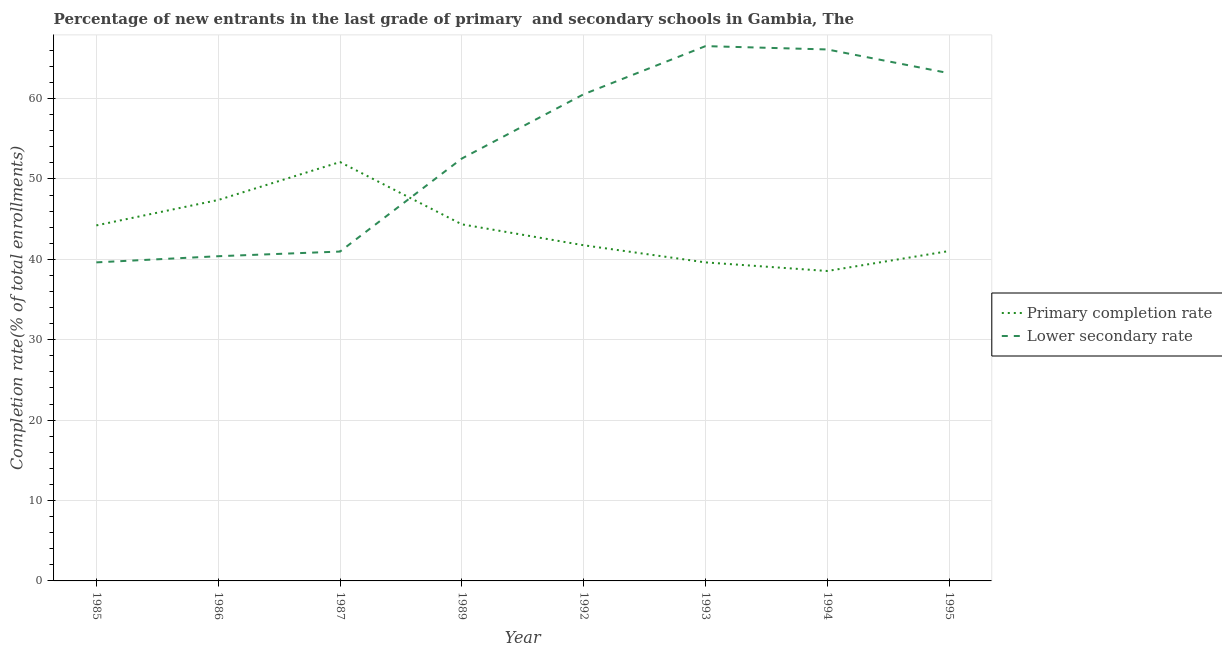How many different coloured lines are there?
Your answer should be compact. 2. Does the line corresponding to completion rate in secondary schools intersect with the line corresponding to completion rate in primary schools?
Keep it short and to the point. Yes. What is the completion rate in secondary schools in 1993?
Offer a very short reply. 66.53. Across all years, what is the maximum completion rate in primary schools?
Give a very brief answer. 52.11. Across all years, what is the minimum completion rate in secondary schools?
Give a very brief answer. 39.63. In which year was the completion rate in primary schools maximum?
Offer a very short reply. 1987. What is the total completion rate in secondary schools in the graph?
Offer a terse response. 429.88. What is the difference between the completion rate in primary schools in 1993 and that in 1995?
Your answer should be very brief. -1.41. What is the difference between the completion rate in primary schools in 1994 and the completion rate in secondary schools in 1992?
Offer a terse response. -21.99. What is the average completion rate in primary schools per year?
Provide a succinct answer. 43.63. In the year 1993, what is the difference between the completion rate in secondary schools and completion rate in primary schools?
Your answer should be compact. 26.9. In how many years, is the completion rate in primary schools greater than 40 %?
Give a very brief answer. 6. What is the ratio of the completion rate in primary schools in 1986 to that in 1994?
Make the answer very short. 1.23. Is the completion rate in primary schools in 1993 less than that in 1995?
Provide a succinct answer. Yes. What is the difference between the highest and the second highest completion rate in secondary schools?
Your answer should be compact. 0.42. What is the difference between the highest and the lowest completion rate in primary schools?
Offer a terse response. 13.55. Does the completion rate in secondary schools monotonically increase over the years?
Ensure brevity in your answer.  No. Is the completion rate in primary schools strictly greater than the completion rate in secondary schools over the years?
Your response must be concise. No. Is the completion rate in primary schools strictly less than the completion rate in secondary schools over the years?
Offer a terse response. No. What is the difference between two consecutive major ticks on the Y-axis?
Your answer should be very brief. 10. Does the graph contain any zero values?
Your answer should be compact. No. How many legend labels are there?
Keep it short and to the point. 2. How are the legend labels stacked?
Offer a very short reply. Vertical. What is the title of the graph?
Your answer should be compact. Percentage of new entrants in the last grade of primary  and secondary schools in Gambia, The. Does "Register a property" appear as one of the legend labels in the graph?
Keep it short and to the point. No. What is the label or title of the X-axis?
Provide a short and direct response. Year. What is the label or title of the Y-axis?
Your answer should be compact. Completion rate(% of total enrollments). What is the Completion rate(% of total enrollments) in Primary completion rate in 1985?
Your answer should be compact. 44.23. What is the Completion rate(% of total enrollments) of Lower secondary rate in 1985?
Provide a short and direct response. 39.63. What is the Completion rate(% of total enrollments) of Primary completion rate in 1986?
Keep it short and to the point. 47.39. What is the Completion rate(% of total enrollments) in Lower secondary rate in 1986?
Ensure brevity in your answer.  40.39. What is the Completion rate(% of total enrollments) of Primary completion rate in 1987?
Provide a succinct answer. 52.11. What is the Completion rate(% of total enrollments) in Lower secondary rate in 1987?
Keep it short and to the point. 40.97. What is the Completion rate(% of total enrollments) in Primary completion rate in 1989?
Offer a very short reply. 44.36. What is the Completion rate(% of total enrollments) in Lower secondary rate in 1989?
Your response must be concise. 52.55. What is the Completion rate(% of total enrollments) of Primary completion rate in 1992?
Keep it short and to the point. 41.76. What is the Completion rate(% of total enrollments) of Lower secondary rate in 1992?
Give a very brief answer. 60.54. What is the Completion rate(% of total enrollments) of Primary completion rate in 1993?
Ensure brevity in your answer.  39.63. What is the Completion rate(% of total enrollments) of Lower secondary rate in 1993?
Your answer should be compact. 66.53. What is the Completion rate(% of total enrollments) of Primary completion rate in 1994?
Your response must be concise. 38.55. What is the Completion rate(% of total enrollments) in Lower secondary rate in 1994?
Your answer should be very brief. 66.11. What is the Completion rate(% of total enrollments) of Primary completion rate in 1995?
Provide a short and direct response. 41.04. What is the Completion rate(% of total enrollments) of Lower secondary rate in 1995?
Your answer should be very brief. 63.16. Across all years, what is the maximum Completion rate(% of total enrollments) of Primary completion rate?
Give a very brief answer. 52.11. Across all years, what is the maximum Completion rate(% of total enrollments) in Lower secondary rate?
Make the answer very short. 66.53. Across all years, what is the minimum Completion rate(% of total enrollments) of Primary completion rate?
Provide a short and direct response. 38.55. Across all years, what is the minimum Completion rate(% of total enrollments) in Lower secondary rate?
Keep it short and to the point. 39.63. What is the total Completion rate(% of total enrollments) of Primary completion rate in the graph?
Provide a short and direct response. 349.05. What is the total Completion rate(% of total enrollments) in Lower secondary rate in the graph?
Make the answer very short. 429.88. What is the difference between the Completion rate(% of total enrollments) in Primary completion rate in 1985 and that in 1986?
Provide a short and direct response. -3.16. What is the difference between the Completion rate(% of total enrollments) in Lower secondary rate in 1985 and that in 1986?
Give a very brief answer. -0.77. What is the difference between the Completion rate(% of total enrollments) in Primary completion rate in 1985 and that in 1987?
Ensure brevity in your answer.  -7.88. What is the difference between the Completion rate(% of total enrollments) in Lower secondary rate in 1985 and that in 1987?
Ensure brevity in your answer.  -1.35. What is the difference between the Completion rate(% of total enrollments) of Primary completion rate in 1985 and that in 1989?
Provide a short and direct response. -0.13. What is the difference between the Completion rate(% of total enrollments) of Lower secondary rate in 1985 and that in 1989?
Your answer should be compact. -12.92. What is the difference between the Completion rate(% of total enrollments) of Primary completion rate in 1985 and that in 1992?
Your answer should be compact. 2.47. What is the difference between the Completion rate(% of total enrollments) in Lower secondary rate in 1985 and that in 1992?
Offer a terse response. -20.92. What is the difference between the Completion rate(% of total enrollments) in Primary completion rate in 1985 and that in 1993?
Your response must be concise. 4.6. What is the difference between the Completion rate(% of total enrollments) in Lower secondary rate in 1985 and that in 1993?
Provide a succinct answer. -26.9. What is the difference between the Completion rate(% of total enrollments) of Primary completion rate in 1985 and that in 1994?
Keep it short and to the point. 5.67. What is the difference between the Completion rate(% of total enrollments) in Lower secondary rate in 1985 and that in 1994?
Provide a short and direct response. -26.49. What is the difference between the Completion rate(% of total enrollments) in Primary completion rate in 1985 and that in 1995?
Give a very brief answer. 3.19. What is the difference between the Completion rate(% of total enrollments) in Lower secondary rate in 1985 and that in 1995?
Provide a short and direct response. -23.53. What is the difference between the Completion rate(% of total enrollments) of Primary completion rate in 1986 and that in 1987?
Offer a very short reply. -4.72. What is the difference between the Completion rate(% of total enrollments) of Lower secondary rate in 1986 and that in 1987?
Your answer should be compact. -0.58. What is the difference between the Completion rate(% of total enrollments) of Primary completion rate in 1986 and that in 1989?
Provide a succinct answer. 3.03. What is the difference between the Completion rate(% of total enrollments) of Lower secondary rate in 1986 and that in 1989?
Provide a succinct answer. -12.15. What is the difference between the Completion rate(% of total enrollments) in Primary completion rate in 1986 and that in 1992?
Your answer should be compact. 5.63. What is the difference between the Completion rate(% of total enrollments) in Lower secondary rate in 1986 and that in 1992?
Provide a succinct answer. -20.15. What is the difference between the Completion rate(% of total enrollments) in Primary completion rate in 1986 and that in 1993?
Offer a very short reply. 7.76. What is the difference between the Completion rate(% of total enrollments) of Lower secondary rate in 1986 and that in 1993?
Ensure brevity in your answer.  -26.14. What is the difference between the Completion rate(% of total enrollments) in Primary completion rate in 1986 and that in 1994?
Your answer should be compact. 8.83. What is the difference between the Completion rate(% of total enrollments) of Lower secondary rate in 1986 and that in 1994?
Ensure brevity in your answer.  -25.72. What is the difference between the Completion rate(% of total enrollments) in Primary completion rate in 1986 and that in 1995?
Your answer should be very brief. 6.35. What is the difference between the Completion rate(% of total enrollments) in Lower secondary rate in 1986 and that in 1995?
Your answer should be compact. -22.76. What is the difference between the Completion rate(% of total enrollments) of Primary completion rate in 1987 and that in 1989?
Keep it short and to the point. 7.75. What is the difference between the Completion rate(% of total enrollments) of Lower secondary rate in 1987 and that in 1989?
Provide a short and direct response. -11.57. What is the difference between the Completion rate(% of total enrollments) of Primary completion rate in 1987 and that in 1992?
Your response must be concise. 10.35. What is the difference between the Completion rate(% of total enrollments) in Lower secondary rate in 1987 and that in 1992?
Provide a short and direct response. -19.57. What is the difference between the Completion rate(% of total enrollments) of Primary completion rate in 1987 and that in 1993?
Your answer should be very brief. 12.48. What is the difference between the Completion rate(% of total enrollments) in Lower secondary rate in 1987 and that in 1993?
Provide a succinct answer. -25.56. What is the difference between the Completion rate(% of total enrollments) in Primary completion rate in 1987 and that in 1994?
Give a very brief answer. 13.55. What is the difference between the Completion rate(% of total enrollments) in Lower secondary rate in 1987 and that in 1994?
Ensure brevity in your answer.  -25.14. What is the difference between the Completion rate(% of total enrollments) of Primary completion rate in 1987 and that in 1995?
Ensure brevity in your answer.  11.07. What is the difference between the Completion rate(% of total enrollments) of Lower secondary rate in 1987 and that in 1995?
Your answer should be very brief. -22.19. What is the difference between the Completion rate(% of total enrollments) in Primary completion rate in 1989 and that in 1992?
Your answer should be compact. 2.6. What is the difference between the Completion rate(% of total enrollments) of Lower secondary rate in 1989 and that in 1992?
Give a very brief answer. -8. What is the difference between the Completion rate(% of total enrollments) of Primary completion rate in 1989 and that in 1993?
Your answer should be very brief. 4.73. What is the difference between the Completion rate(% of total enrollments) of Lower secondary rate in 1989 and that in 1993?
Your response must be concise. -13.98. What is the difference between the Completion rate(% of total enrollments) of Primary completion rate in 1989 and that in 1994?
Offer a very short reply. 5.8. What is the difference between the Completion rate(% of total enrollments) in Lower secondary rate in 1989 and that in 1994?
Offer a terse response. -13.57. What is the difference between the Completion rate(% of total enrollments) in Primary completion rate in 1989 and that in 1995?
Keep it short and to the point. 3.32. What is the difference between the Completion rate(% of total enrollments) of Lower secondary rate in 1989 and that in 1995?
Your answer should be very brief. -10.61. What is the difference between the Completion rate(% of total enrollments) of Primary completion rate in 1992 and that in 1993?
Your answer should be very brief. 2.13. What is the difference between the Completion rate(% of total enrollments) in Lower secondary rate in 1992 and that in 1993?
Your response must be concise. -5.99. What is the difference between the Completion rate(% of total enrollments) in Primary completion rate in 1992 and that in 1994?
Keep it short and to the point. 3.2. What is the difference between the Completion rate(% of total enrollments) in Lower secondary rate in 1992 and that in 1994?
Keep it short and to the point. -5.57. What is the difference between the Completion rate(% of total enrollments) of Primary completion rate in 1992 and that in 1995?
Give a very brief answer. 0.72. What is the difference between the Completion rate(% of total enrollments) in Lower secondary rate in 1992 and that in 1995?
Your response must be concise. -2.62. What is the difference between the Completion rate(% of total enrollments) of Primary completion rate in 1993 and that in 1994?
Give a very brief answer. 1.07. What is the difference between the Completion rate(% of total enrollments) in Lower secondary rate in 1993 and that in 1994?
Offer a very short reply. 0.42. What is the difference between the Completion rate(% of total enrollments) of Primary completion rate in 1993 and that in 1995?
Offer a terse response. -1.41. What is the difference between the Completion rate(% of total enrollments) in Lower secondary rate in 1993 and that in 1995?
Your response must be concise. 3.37. What is the difference between the Completion rate(% of total enrollments) in Primary completion rate in 1994 and that in 1995?
Give a very brief answer. -2.48. What is the difference between the Completion rate(% of total enrollments) of Lower secondary rate in 1994 and that in 1995?
Provide a short and direct response. 2.96. What is the difference between the Completion rate(% of total enrollments) in Primary completion rate in 1985 and the Completion rate(% of total enrollments) in Lower secondary rate in 1986?
Make the answer very short. 3.83. What is the difference between the Completion rate(% of total enrollments) in Primary completion rate in 1985 and the Completion rate(% of total enrollments) in Lower secondary rate in 1987?
Offer a very short reply. 3.26. What is the difference between the Completion rate(% of total enrollments) in Primary completion rate in 1985 and the Completion rate(% of total enrollments) in Lower secondary rate in 1989?
Your response must be concise. -8.32. What is the difference between the Completion rate(% of total enrollments) in Primary completion rate in 1985 and the Completion rate(% of total enrollments) in Lower secondary rate in 1992?
Offer a very short reply. -16.31. What is the difference between the Completion rate(% of total enrollments) in Primary completion rate in 1985 and the Completion rate(% of total enrollments) in Lower secondary rate in 1993?
Provide a succinct answer. -22.3. What is the difference between the Completion rate(% of total enrollments) in Primary completion rate in 1985 and the Completion rate(% of total enrollments) in Lower secondary rate in 1994?
Make the answer very short. -21.89. What is the difference between the Completion rate(% of total enrollments) of Primary completion rate in 1985 and the Completion rate(% of total enrollments) of Lower secondary rate in 1995?
Make the answer very short. -18.93. What is the difference between the Completion rate(% of total enrollments) of Primary completion rate in 1986 and the Completion rate(% of total enrollments) of Lower secondary rate in 1987?
Your response must be concise. 6.41. What is the difference between the Completion rate(% of total enrollments) in Primary completion rate in 1986 and the Completion rate(% of total enrollments) in Lower secondary rate in 1989?
Provide a succinct answer. -5.16. What is the difference between the Completion rate(% of total enrollments) of Primary completion rate in 1986 and the Completion rate(% of total enrollments) of Lower secondary rate in 1992?
Provide a succinct answer. -13.16. What is the difference between the Completion rate(% of total enrollments) in Primary completion rate in 1986 and the Completion rate(% of total enrollments) in Lower secondary rate in 1993?
Make the answer very short. -19.14. What is the difference between the Completion rate(% of total enrollments) of Primary completion rate in 1986 and the Completion rate(% of total enrollments) of Lower secondary rate in 1994?
Provide a succinct answer. -18.73. What is the difference between the Completion rate(% of total enrollments) in Primary completion rate in 1986 and the Completion rate(% of total enrollments) in Lower secondary rate in 1995?
Your answer should be compact. -15.77. What is the difference between the Completion rate(% of total enrollments) in Primary completion rate in 1987 and the Completion rate(% of total enrollments) in Lower secondary rate in 1989?
Your answer should be very brief. -0.44. What is the difference between the Completion rate(% of total enrollments) in Primary completion rate in 1987 and the Completion rate(% of total enrollments) in Lower secondary rate in 1992?
Your response must be concise. -8.44. What is the difference between the Completion rate(% of total enrollments) in Primary completion rate in 1987 and the Completion rate(% of total enrollments) in Lower secondary rate in 1993?
Offer a terse response. -14.42. What is the difference between the Completion rate(% of total enrollments) of Primary completion rate in 1987 and the Completion rate(% of total enrollments) of Lower secondary rate in 1994?
Keep it short and to the point. -14.01. What is the difference between the Completion rate(% of total enrollments) in Primary completion rate in 1987 and the Completion rate(% of total enrollments) in Lower secondary rate in 1995?
Offer a terse response. -11.05. What is the difference between the Completion rate(% of total enrollments) of Primary completion rate in 1989 and the Completion rate(% of total enrollments) of Lower secondary rate in 1992?
Provide a succinct answer. -16.18. What is the difference between the Completion rate(% of total enrollments) of Primary completion rate in 1989 and the Completion rate(% of total enrollments) of Lower secondary rate in 1993?
Keep it short and to the point. -22.17. What is the difference between the Completion rate(% of total enrollments) of Primary completion rate in 1989 and the Completion rate(% of total enrollments) of Lower secondary rate in 1994?
Offer a very short reply. -21.75. What is the difference between the Completion rate(% of total enrollments) of Primary completion rate in 1989 and the Completion rate(% of total enrollments) of Lower secondary rate in 1995?
Keep it short and to the point. -18.8. What is the difference between the Completion rate(% of total enrollments) in Primary completion rate in 1992 and the Completion rate(% of total enrollments) in Lower secondary rate in 1993?
Your response must be concise. -24.77. What is the difference between the Completion rate(% of total enrollments) in Primary completion rate in 1992 and the Completion rate(% of total enrollments) in Lower secondary rate in 1994?
Your answer should be compact. -24.36. What is the difference between the Completion rate(% of total enrollments) in Primary completion rate in 1992 and the Completion rate(% of total enrollments) in Lower secondary rate in 1995?
Your answer should be compact. -21.4. What is the difference between the Completion rate(% of total enrollments) of Primary completion rate in 1993 and the Completion rate(% of total enrollments) of Lower secondary rate in 1994?
Provide a succinct answer. -26.49. What is the difference between the Completion rate(% of total enrollments) in Primary completion rate in 1993 and the Completion rate(% of total enrollments) in Lower secondary rate in 1995?
Offer a terse response. -23.53. What is the difference between the Completion rate(% of total enrollments) in Primary completion rate in 1994 and the Completion rate(% of total enrollments) in Lower secondary rate in 1995?
Offer a very short reply. -24.6. What is the average Completion rate(% of total enrollments) in Primary completion rate per year?
Give a very brief answer. 43.63. What is the average Completion rate(% of total enrollments) in Lower secondary rate per year?
Ensure brevity in your answer.  53.73. In the year 1985, what is the difference between the Completion rate(% of total enrollments) of Primary completion rate and Completion rate(% of total enrollments) of Lower secondary rate?
Give a very brief answer. 4.6. In the year 1986, what is the difference between the Completion rate(% of total enrollments) in Primary completion rate and Completion rate(% of total enrollments) in Lower secondary rate?
Offer a very short reply. 6.99. In the year 1987, what is the difference between the Completion rate(% of total enrollments) in Primary completion rate and Completion rate(% of total enrollments) in Lower secondary rate?
Your answer should be compact. 11.13. In the year 1989, what is the difference between the Completion rate(% of total enrollments) of Primary completion rate and Completion rate(% of total enrollments) of Lower secondary rate?
Give a very brief answer. -8.19. In the year 1992, what is the difference between the Completion rate(% of total enrollments) of Primary completion rate and Completion rate(% of total enrollments) of Lower secondary rate?
Your answer should be compact. -18.79. In the year 1993, what is the difference between the Completion rate(% of total enrollments) in Primary completion rate and Completion rate(% of total enrollments) in Lower secondary rate?
Offer a terse response. -26.9. In the year 1994, what is the difference between the Completion rate(% of total enrollments) in Primary completion rate and Completion rate(% of total enrollments) in Lower secondary rate?
Your answer should be very brief. -27.56. In the year 1995, what is the difference between the Completion rate(% of total enrollments) in Primary completion rate and Completion rate(% of total enrollments) in Lower secondary rate?
Your answer should be very brief. -22.12. What is the ratio of the Completion rate(% of total enrollments) in Lower secondary rate in 1985 to that in 1986?
Keep it short and to the point. 0.98. What is the ratio of the Completion rate(% of total enrollments) of Primary completion rate in 1985 to that in 1987?
Make the answer very short. 0.85. What is the ratio of the Completion rate(% of total enrollments) in Lower secondary rate in 1985 to that in 1987?
Give a very brief answer. 0.97. What is the ratio of the Completion rate(% of total enrollments) of Lower secondary rate in 1985 to that in 1989?
Make the answer very short. 0.75. What is the ratio of the Completion rate(% of total enrollments) of Primary completion rate in 1985 to that in 1992?
Offer a terse response. 1.06. What is the ratio of the Completion rate(% of total enrollments) in Lower secondary rate in 1985 to that in 1992?
Your answer should be compact. 0.65. What is the ratio of the Completion rate(% of total enrollments) in Primary completion rate in 1985 to that in 1993?
Give a very brief answer. 1.12. What is the ratio of the Completion rate(% of total enrollments) of Lower secondary rate in 1985 to that in 1993?
Your answer should be very brief. 0.6. What is the ratio of the Completion rate(% of total enrollments) in Primary completion rate in 1985 to that in 1994?
Give a very brief answer. 1.15. What is the ratio of the Completion rate(% of total enrollments) of Lower secondary rate in 1985 to that in 1994?
Offer a terse response. 0.6. What is the ratio of the Completion rate(% of total enrollments) of Primary completion rate in 1985 to that in 1995?
Your answer should be very brief. 1.08. What is the ratio of the Completion rate(% of total enrollments) of Lower secondary rate in 1985 to that in 1995?
Offer a very short reply. 0.63. What is the ratio of the Completion rate(% of total enrollments) of Primary completion rate in 1986 to that in 1987?
Offer a terse response. 0.91. What is the ratio of the Completion rate(% of total enrollments) of Lower secondary rate in 1986 to that in 1987?
Offer a very short reply. 0.99. What is the ratio of the Completion rate(% of total enrollments) of Primary completion rate in 1986 to that in 1989?
Provide a short and direct response. 1.07. What is the ratio of the Completion rate(% of total enrollments) in Lower secondary rate in 1986 to that in 1989?
Make the answer very short. 0.77. What is the ratio of the Completion rate(% of total enrollments) of Primary completion rate in 1986 to that in 1992?
Provide a short and direct response. 1.13. What is the ratio of the Completion rate(% of total enrollments) in Lower secondary rate in 1986 to that in 1992?
Keep it short and to the point. 0.67. What is the ratio of the Completion rate(% of total enrollments) of Primary completion rate in 1986 to that in 1993?
Offer a terse response. 1.2. What is the ratio of the Completion rate(% of total enrollments) of Lower secondary rate in 1986 to that in 1993?
Provide a succinct answer. 0.61. What is the ratio of the Completion rate(% of total enrollments) in Primary completion rate in 1986 to that in 1994?
Ensure brevity in your answer.  1.23. What is the ratio of the Completion rate(% of total enrollments) in Lower secondary rate in 1986 to that in 1994?
Offer a very short reply. 0.61. What is the ratio of the Completion rate(% of total enrollments) of Primary completion rate in 1986 to that in 1995?
Keep it short and to the point. 1.15. What is the ratio of the Completion rate(% of total enrollments) in Lower secondary rate in 1986 to that in 1995?
Ensure brevity in your answer.  0.64. What is the ratio of the Completion rate(% of total enrollments) in Primary completion rate in 1987 to that in 1989?
Your answer should be compact. 1.17. What is the ratio of the Completion rate(% of total enrollments) in Lower secondary rate in 1987 to that in 1989?
Keep it short and to the point. 0.78. What is the ratio of the Completion rate(% of total enrollments) in Primary completion rate in 1987 to that in 1992?
Your answer should be very brief. 1.25. What is the ratio of the Completion rate(% of total enrollments) of Lower secondary rate in 1987 to that in 1992?
Make the answer very short. 0.68. What is the ratio of the Completion rate(% of total enrollments) of Primary completion rate in 1987 to that in 1993?
Offer a very short reply. 1.31. What is the ratio of the Completion rate(% of total enrollments) of Lower secondary rate in 1987 to that in 1993?
Offer a very short reply. 0.62. What is the ratio of the Completion rate(% of total enrollments) of Primary completion rate in 1987 to that in 1994?
Provide a short and direct response. 1.35. What is the ratio of the Completion rate(% of total enrollments) of Lower secondary rate in 1987 to that in 1994?
Provide a short and direct response. 0.62. What is the ratio of the Completion rate(% of total enrollments) of Primary completion rate in 1987 to that in 1995?
Offer a terse response. 1.27. What is the ratio of the Completion rate(% of total enrollments) in Lower secondary rate in 1987 to that in 1995?
Give a very brief answer. 0.65. What is the ratio of the Completion rate(% of total enrollments) of Primary completion rate in 1989 to that in 1992?
Provide a short and direct response. 1.06. What is the ratio of the Completion rate(% of total enrollments) of Lower secondary rate in 1989 to that in 1992?
Your answer should be very brief. 0.87. What is the ratio of the Completion rate(% of total enrollments) in Primary completion rate in 1989 to that in 1993?
Offer a very short reply. 1.12. What is the ratio of the Completion rate(% of total enrollments) of Lower secondary rate in 1989 to that in 1993?
Make the answer very short. 0.79. What is the ratio of the Completion rate(% of total enrollments) of Primary completion rate in 1989 to that in 1994?
Provide a short and direct response. 1.15. What is the ratio of the Completion rate(% of total enrollments) in Lower secondary rate in 1989 to that in 1994?
Keep it short and to the point. 0.79. What is the ratio of the Completion rate(% of total enrollments) in Primary completion rate in 1989 to that in 1995?
Offer a terse response. 1.08. What is the ratio of the Completion rate(% of total enrollments) in Lower secondary rate in 1989 to that in 1995?
Offer a very short reply. 0.83. What is the ratio of the Completion rate(% of total enrollments) in Primary completion rate in 1992 to that in 1993?
Keep it short and to the point. 1.05. What is the ratio of the Completion rate(% of total enrollments) of Lower secondary rate in 1992 to that in 1993?
Your answer should be very brief. 0.91. What is the ratio of the Completion rate(% of total enrollments) of Primary completion rate in 1992 to that in 1994?
Your response must be concise. 1.08. What is the ratio of the Completion rate(% of total enrollments) in Lower secondary rate in 1992 to that in 1994?
Ensure brevity in your answer.  0.92. What is the ratio of the Completion rate(% of total enrollments) of Primary completion rate in 1992 to that in 1995?
Your answer should be compact. 1.02. What is the ratio of the Completion rate(% of total enrollments) of Lower secondary rate in 1992 to that in 1995?
Make the answer very short. 0.96. What is the ratio of the Completion rate(% of total enrollments) in Primary completion rate in 1993 to that in 1994?
Offer a terse response. 1.03. What is the ratio of the Completion rate(% of total enrollments) of Lower secondary rate in 1993 to that in 1994?
Your response must be concise. 1.01. What is the ratio of the Completion rate(% of total enrollments) in Primary completion rate in 1993 to that in 1995?
Ensure brevity in your answer.  0.97. What is the ratio of the Completion rate(% of total enrollments) of Lower secondary rate in 1993 to that in 1995?
Provide a short and direct response. 1.05. What is the ratio of the Completion rate(% of total enrollments) of Primary completion rate in 1994 to that in 1995?
Keep it short and to the point. 0.94. What is the ratio of the Completion rate(% of total enrollments) in Lower secondary rate in 1994 to that in 1995?
Your answer should be very brief. 1.05. What is the difference between the highest and the second highest Completion rate(% of total enrollments) in Primary completion rate?
Your answer should be very brief. 4.72. What is the difference between the highest and the second highest Completion rate(% of total enrollments) of Lower secondary rate?
Offer a very short reply. 0.42. What is the difference between the highest and the lowest Completion rate(% of total enrollments) of Primary completion rate?
Your answer should be compact. 13.55. What is the difference between the highest and the lowest Completion rate(% of total enrollments) of Lower secondary rate?
Your answer should be very brief. 26.9. 